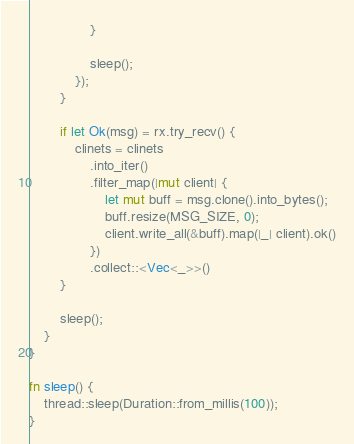<code> <loc_0><loc_0><loc_500><loc_500><_Rust_>                }

                sleep();
            });
        }

        if let Ok(msg) = rx.try_recv() {
            clinets = clinets
                .into_iter()
                .filter_map(|mut client| {
                    let mut buff = msg.clone().into_bytes();
                    buff.resize(MSG_SIZE, 0);
                    client.write_all(&buff).map(|_| client).ok()
                })
                .collect::<Vec<_>>()
        }

        sleep();
    }
}

fn sleep() {
    thread::sleep(Duration::from_millis(100));
}
</code> 